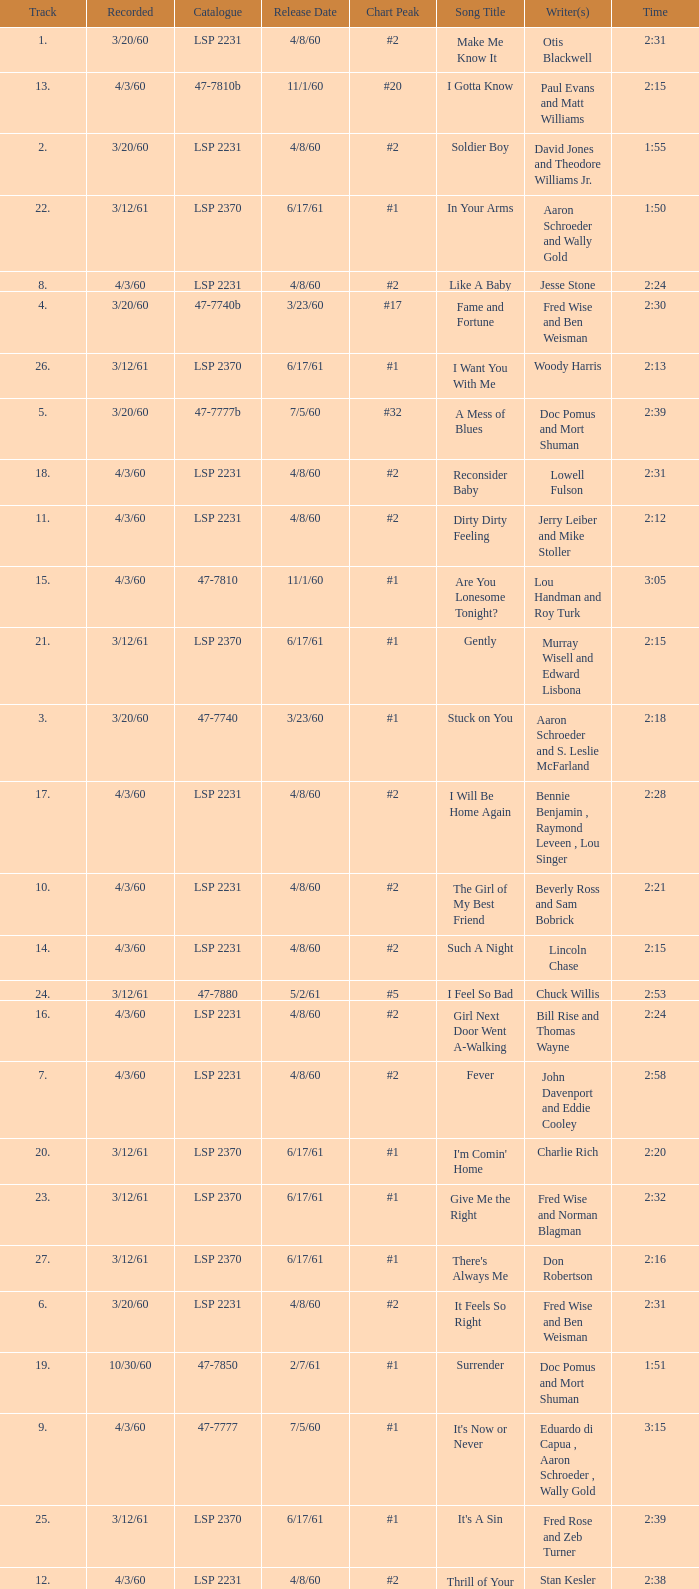What catalogue is the song It's Now or Never? 47-7777. 